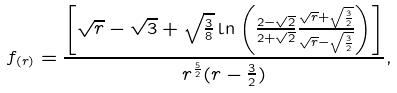<formula> <loc_0><loc_0><loc_500><loc_500>f _ { ( r ) } = \frac { \left [ \sqrt { r } - \sqrt { 3 } + \sqrt { \frac { 3 } { 8 } } \ln \left ( \frac { 2 - \sqrt { 2 } } { 2 + \sqrt { 2 } } \frac { \sqrt { r } + \sqrt { \frac { 3 } { 2 } } } { \sqrt { r } - \sqrt { \frac { 3 } { 2 } } } \right ) \right ] } { r ^ { \frac { 5 } { 2 } } ( r - \frac { 3 } { 2 } ) } ,</formula> 